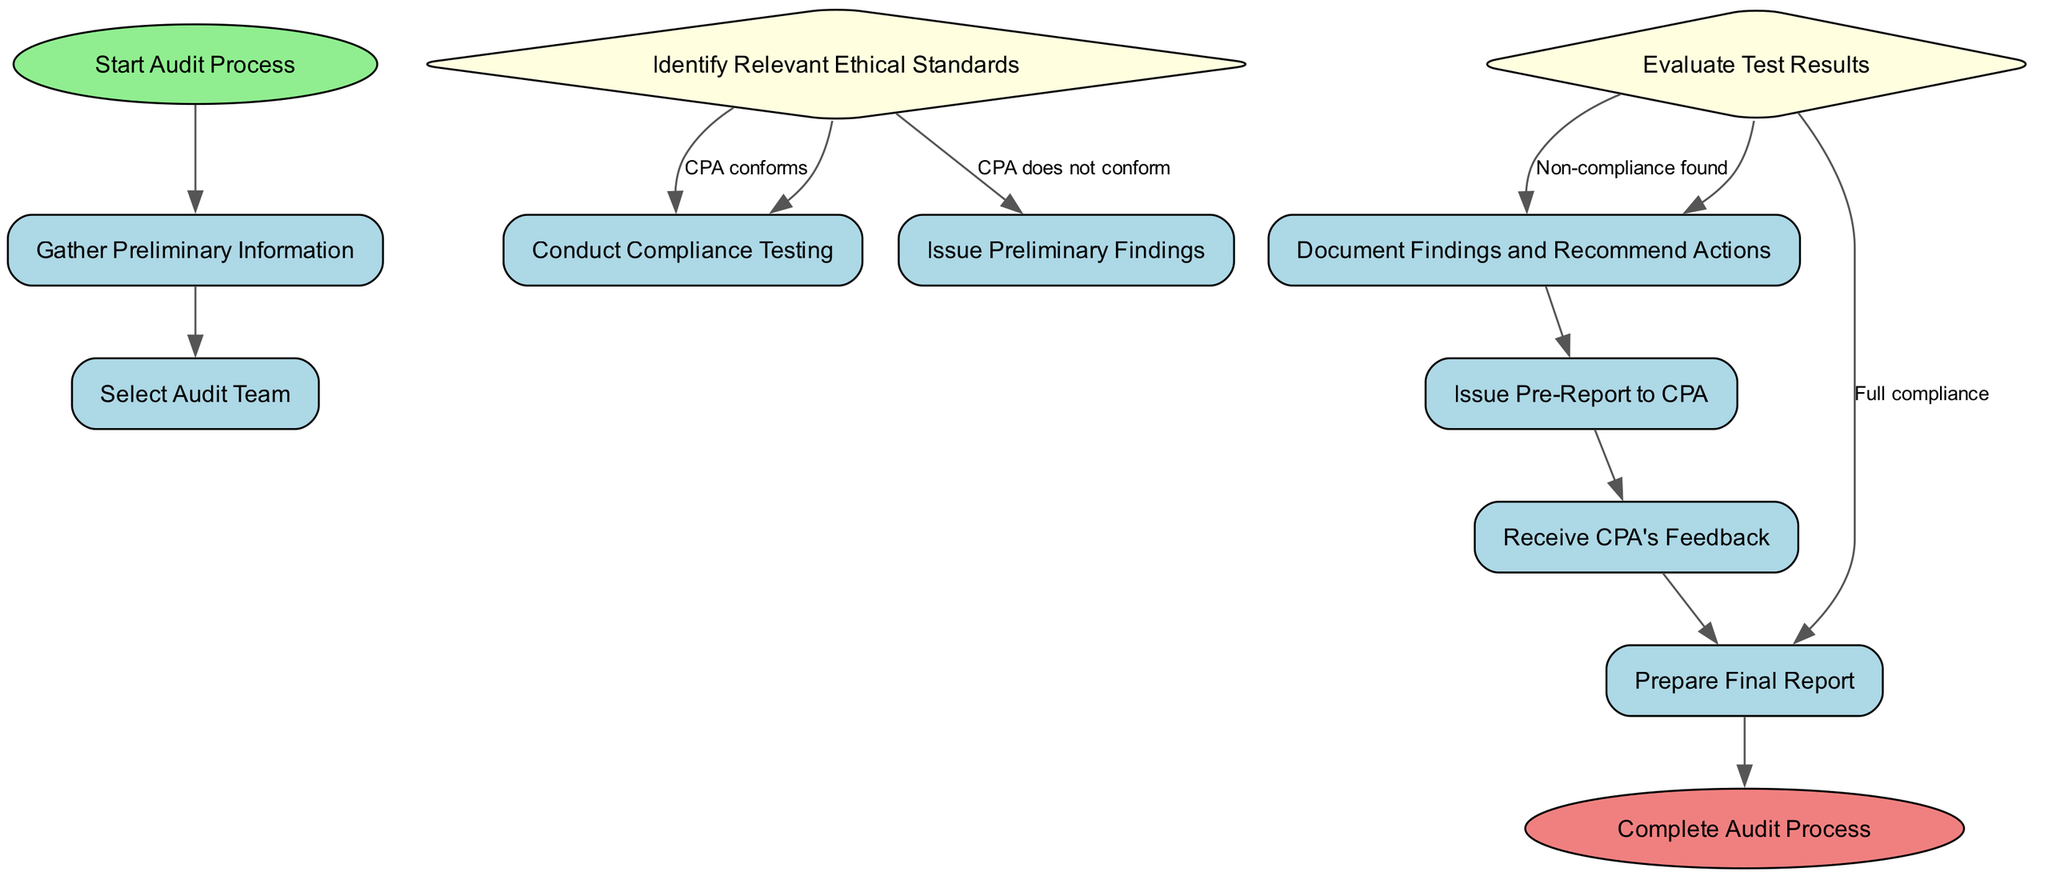What is the first action in the audit process? The first action in the audit process is "Gather Preliminary Information" as indicated in the diagram following the start node.
Answer: Gather Preliminary Information How many total actions are present in the diagram? The diagram contains three actions: "Gather Preliminary Information," "Conduct Compliance Testing," and "Document Findings and Recommend Actions."
Answer: Three What happens if the CPA conforms to the ethical standards? If the CPA conforms to the ethical standards, the next step is "Conduct Compliance Testing," which follows from the decision made after identifying the relevant ethical standards.
Answer: Conduct Compliance Testing What is the output if non-compliance is found in the evaluation of test results? If non-compliance is found, the next action is "Document Findings and Recommend Actions" which represents the course of action taken following the evaluation of test results.
Answer: Document Findings and Recommend Actions How many decision points are there in the diagram? There are two decision points in the diagram: "Identify Relevant Ethical Standards" and "Evaluate Test Results," which guide the flow of actions based on conditions assessed.
Answer: Two What is the final action before completing the audit process? The final action before completing the audit process is "Prepare Final Report," which comes before reaching the end node of the process diagram.
Answer: Prepare Final Report What is issued after documenting findings? After documenting findings, the action taken is "Issue Pre-Report to CPA," which allows for CPA feedback before finalizing the report.
Answer: Issue Pre-Report to CPA What indicates a successful outcome of compliance testing? A successful outcome of compliance testing is indicated by "Full compliance," leading directly to the action "Prepare Final Report."
Answer: Full compliance What is the shape of the start node in the diagram? The start node is shaped like an ellipse, which is a standard representation for starting points in activity diagrams.
Answer: Ellipse 